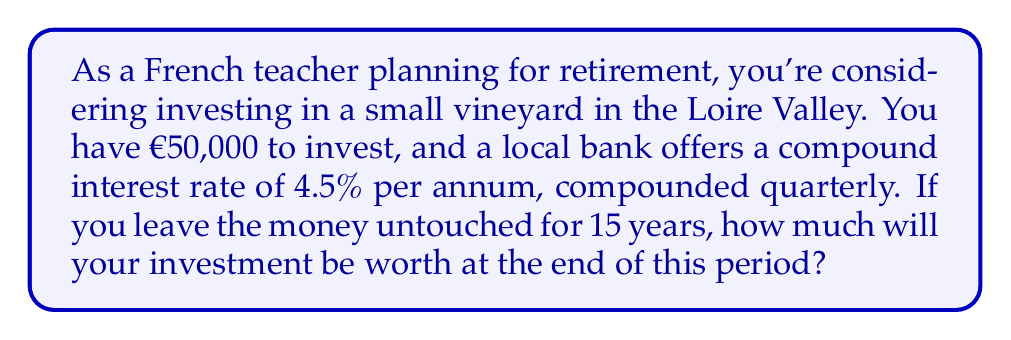What is the answer to this math problem? To solve this problem, we'll use the compound interest formula:

$$A = P(1 + \frac{r}{n})^{nt}$$

Where:
$A$ = final amount
$P$ = principal (initial investment)
$r$ = annual interest rate (as a decimal)
$n$ = number of times interest is compounded per year
$t$ = number of years

Given:
$P = €50,000$
$r = 4.5\% = 0.045$
$n = 4$ (compounded quarterly)
$t = 15$ years

Let's substitute these values into the formula:

$$A = 50000(1 + \frac{0.045}{4})^{4(15)}$$

$$A = 50000(1 + 0.01125)^{60}$$

$$A = 50000(1.01125)^{60}$$

Using a calculator:

$$A = 50000 * 1.959029861$$

$$A = 97951.49$$

Rounding to the nearest cent:

$$A = €97,951.49$$
Answer: €97,951.49 